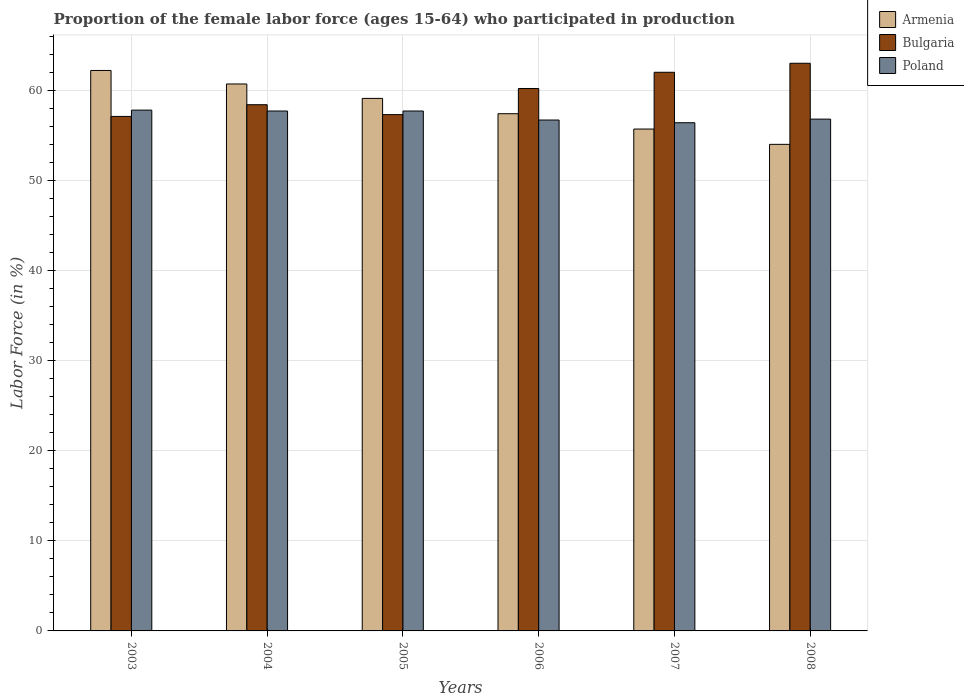How many different coloured bars are there?
Give a very brief answer. 3. How many groups of bars are there?
Offer a very short reply. 6. Are the number of bars per tick equal to the number of legend labels?
Provide a succinct answer. Yes. Are the number of bars on each tick of the X-axis equal?
Give a very brief answer. Yes. What is the label of the 2nd group of bars from the left?
Keep it short and to the point. 2004. In how many cases, is the number of bars for a given year not equal to the number of legend labels?
Keep it short and to the point. 0. Across all years, what is the maximum proportion of the female labor force who participated in production in Poland?
Your answer should be very brief. 57.8. Across all years, what is the minimum proportion of the female labor force who participated in production in Armenia?
Your response must be concise. 54. In which year was the proportion of the female labor force who participated in production in Bulgaria minimum?
Ensure brevity in your answer.  2003. What is the total proportion of the female labor force who participated in production in Bulgaria in the graph?
Keep it short and to the point. 358. What is the difference between the proportion of the female labor force who participated in production in Armenia in 2004 and that in 2005?
Give a very brief answer. 1.6. What is the average proportion of the female labor force who participated in production in Bulgaria per year?
Provide a succinct answer. 59.67. In the year 2007, what is the difference between the proportion of the female labor force who participated in production in Armenia and proportion of the female labor force who participated in production in Poland?
Provide a succinct answer. -0.7. In how many years, is the proportion of the female labor force who participated in production in Armenia greater than 44 %?
Ensure brevity in your answer.  6. What is the ratio of the proportion of the female labor force who participated in production in Armenia in 2005 to that in 2007?
Offer a very short reply. 1.06. Is the proportion of the female labor force who participated in production in Armenia in 2004 less than that in 2008?
Your answer should be very brief. No. Is the difference between the proportion of the female labor force who participated in production in Armenia in 2003 and 2005 greater than the difference between the proportion of the female labor force who participated in production in Poland in 2003 and 2005?
Give a very brief answer. Yes. What is the difference between the highest and the second highest proportion of the female labor force who participated in production in Poland?
Your answer should be very brief. 0.1. What is the difference between the highest and the lowest proportion of the female labor force who participated in production in Poland?
Give a very brief answer. 1.4. In how many years, is the proportion of the female labor force who participated in production in Poland greater than the average proportion of the female labor force who participated in production in Poland taken over all years?
Make the answer very short. 3. What does the 1st bar from the left in 2007 represents?
Your response must be concise. Armenia. What does the 3rd bar from the right in 2007 represents?
Your answer should be very brief. Armenia. What is the difference between two consecutive major ticks on the Y-axis?
Your answer should be compact. 10. Are the values on the major ticks of Y-axis written in scientific E-notation?
Give a very brief answer. No. Does the graph contain any zero values?
Offer a terse response. No. Does the graph contain grids?
Offer a terse response. Yes. What is the title of the graph?
Your response must be concise. Proportion of the female labor force (ages 15-64) who participated in production. Does "Singapore" appear as one of the legend labels in the graph?
Your answer should be compact. No. What is the label or title of the Y-axis?
Offer a terse response. Labor Force (in %). What is the Labor Force (in %) in Armenia in 2003?
Provide a succinct answer. 62.2. What is the Labor Force (in %) in Bulgaria in 2003?
Provide a short and direct response. 57.1. What is the Labor Force (in %) of Poland in 2003?
Your answer should be compact. 57.8. What is the Labor Force (in %) of Armenia in 2004?
Make the answer very short. 60.7. What is the Labor Force (in %) of Bulgaria in 2004?
Offer a very short reply. 58.4. What is the Labor Force (in %) of Poland in 2004?
Provide a succinct answer. 57.7. What is the Labor Force (in %) in Armenia in 2005?
Your response must be concise. 59.1. What is the Labor Force (in %) of Bulgaria in 2005?
Your answer should be very brief. 57.3. What is the Labor Force (in %) of Poland in 2005?
Keep it short and to the point. 57.7. What is the Labor Force (in %) of Armenia in 2006?
Your response must be concise. 57.4. What is the Labor Force (in %) in Bulgaria in 2006?
Your response must be concise. 60.2. What is the Labor Force (in %) in Poland in 2006?
Keep it short and to the point. 56.7. What is the Labor Force (in %) in Armenia in 2007?
Your answer should be compact. 55.7. What is the Labor Force (in %) in Poland in 2007?
Keep it short and to the point. 56.4. What is the Labor Force (in %) in Armenia in 2008?
Offer a terse response. 54. What is the Labor Force (in %) in Bulgaria in 2008?
Offer a very short reply. 63. What is the Labor Force (in %) of Poland in 2008?
Ensure brevity in your answer.  56.8. Across all years, what is the maximum Labor Force (in %) of Armenia?
Provide a short and direct response. 62.2. Across all years, what is the maximum Labor Force (in %) in Bulgaria?
Your response must be concise. 63. Across all years, what is the maximum Labor Force (in %) of Poland?
Your answer should be compact. 57.8. Across all years, what is the minimum Labor Force (in %) in Armenia?
Give a very brief answer. 54. Across all years, what is the minimum Labor Force (in %) in Bulgaria?
Give a very brief answer. 57.1. Across all years, what is the minimum Labor Force (in %) in Poland?
Make the answer very short. 56.4. What is the total Labor Force (in %) of Armenia in the graph?
Provide a succinct answer. 349.1. What is the total Labor Force (in %) of Bulgaria in the graph?
Offer a very short reply. 358. What is the total Labor Force (in %) in Poland in the graph?
Your answer should be very brief. 343.1. What is the difference between the Labor Force (in %) of Bulgaria in 2003 and that in 2004?
Offer a very short reply. -1.3. What is the difference between the Labor Force (in %) of Poland in 2003 and that in 2004?
Offer a terse response. 0.1. What is the difference between the Labor Force (in %) of Armenia in 2003 and that in 2005?
Make the answer very short. 3.1. What is the difference between the Labor Force (in %) of Bulgaria in 2003 and that in 2005?
Ensure brevity in your answer.  -0.2. What is the difference between the Labor Force (in %) of Poland in 2003 and that in 2005?
Offer a terse response. 0.1. What is the difference between the Labor Force (in %) of Bulgaria in 2003 and that in 2006?
Your response must be concise. -3.1. What is the difference between the Labor Force (in %) of Poland in 2003 and that in 2006?
Keep it short and to the point. 1.1. What is the difference between the Labor Force (in %) in Armenia in 2003 and that in 2007?
Make the answer very short. 6.5. What is the difference between the Labor Force (in %) in Bulgaria in 2003 and that in 2008?
Ensure brevity in your answer.  -5.9. What is the difference between the Labor Force (in %) in Poland in 2003 and that in 2008?
Give a very brief answer. 1. What is the difference between the Labor Force (in %) in Bulgaria in 2004 and that in 2006?
Your answer should be compact. -1.8. What is the difference between the Labor Force (in %) of Poland in 2004 and that in 2006?
Make the answer very short. 1. What is the difference between the Labor Force (in %) of Bulgaria in 2004 and that in 2007?
Give a very brief answer. -3.6. What is the difference between the Labor Force (in %) of Bulgaria in 2005 and that in 2006?
Your answer should be compact. -2.9. What is the difference between the Labor Force (in %) in Poland in 2005 and that in 2006?
Give a very brief answer. 1. What is the difference between the Labor Force (in %) in Poland in 2005 and that in 2007?
Offer a very short reply. 1.3. What is the difference between the Labor Force (in %) of Bulgaria in 2005 and that in 2008?
Make the answer very short. -5.7. What is the difference between the Labor Force (in %) of Poland in 2005 and that in 2008?
Give a very brief answer. 0.9. What is the difference between the Labor Force (in %) of Armenia in 2006 and that in 2007?
Provide a succinct answer. 1.7. What is the difference between the Labor Force (in %) in Poland in 2006 and that in 2007?
Your answer should be very brief. 0.3. What is the difference between the Labor Force (in %) in Poland in 2006 and that in 2008?
Provide a short and direct response. -0.1. What is the difference between the Labor Force (in %) of Poland in 2007 and that in 2008?
Ensure brevity in your answer.  -0.4. What is the difference between the Labor Force (in %) of Bulgaria in 2003 and the Labor Force (in %) of Poland in 2004?
Keep it short and to the point. -0.6. What is the difference between the Labor Force (in %) in Armenia in 2003 and the Labor Force (in %) in Bulgaria in 2006?
Keep it short and to the point. 2. What is the difference between the Labor Force (in %) in Armenia in 2003 and the Labor Force (in %) in Poland in 2006?
Make the answer very short. 5.5. What is the difference between the Labor Force (in %) in Armenia in 2003 and the Labor Force (in %) in Bulgaria in 2007?
Provide a succinct answer. 0.2. What is the difference between the Labor Force (in %) in Bulgaria in 2003 and the Labor Force (in %) in Poland in 2007?
Provide a short and direct response. 0.7. What is the difference between the Labor Force (in %) of Armenia in 2003 and the Labor Force (in %) of Poland in 2008?
Provide a succinct answer. 5.4. What is the difference between the Labor Force (in %) in Bulgaria in 2003 and the Labor Force (in %) in Poland in 2008?
Give a very brief answer. 0.3. What is the difference between the Labor Force (in %) of Armenia in 2004 and the Labor Force (in %) of Poland in 2005?
Offer a very short reply. 3. What is the difference between the Labor Force (in %) in Bulgaria in 2004 and the Labor Force (in %) in Poland in 2005?
Give a very brief answer. 0.7. What is the difference between the Labor Force (in %) of Armenia in 2004 and the Labor Force (in %) of Bulgaria in 2006?
Provide a succinct answer. 0.5. What is the difference between the Labor Force (in %) in Bulgaria in 2004 and the Labor Force (in %) in Poland in 2006?
Your answer should be very brief. 1.7. What is the difference between the Labor Force (in %) of Armenia in 2004 and the Labor Force (in %) of Bulgaria in 2007?
Give a very brief answer. -1.3. What is the difference between the Labor Force (in %) in Armenia in 2004 and the Labor Force (in %) in Poland in 2007?
Offer a very short reply. 4.3. What is the difference between the Labor Force (in %) in Armenia in 2004 and the Labor Force (in %) in Bulgaria in 2008?
Offer a very short reply. -2.3. What is the difference between the Labor Force (in %) of Armenia in 2004 and the Labor Force (in %) of Poland in 2008?
Provide a succinct answer. 3.9. What is the difference between the Labor Force (in %) of Bulgaria in 2004 and the Labor Force (in %) of Poland in 2008?
Keep it short and to the point. 1.6. What is the difference between the Labor Force (in %) in Armenia in 2005 and the Labor Force (in %) in Bulgaria in 2006?
Make the answer very short. -1.1. What is the difference between the Labor Force (in %) of Armenia in 2005 and the Labor Force (in %) of Bulgaria in 2008?
Your response must be concise. -3.9. What is the difference between the Labor Force (in %) of Armenia in 2005 and the Labor Force (in %) of Poland in 2008?
Provide a succinct answer. 2.3. What is the difference between the Labor Force (in %) of Bulgaria in 2005 and the Labor Force (in %) of Poland in 2008?
Your answer should be compact. 0.5. What is the difference between the Labor Force (in %) of Armenia in 2006 and the Labor Force (in %) of Poland in 2007?
Your response must be concise. 1. What is the difference between the Labor Force (in %) of Bulgaria in 2006 and the Labor Force (in %) of Poland in 2008?
Give a very brief answer. 3.4. What is the average Labor Force (in %) of Armenia per year?
Keep it short and to the point. 58.18. What is the average Labor Force (in %) in Bulgaria per year?
Your answer should be compact. 59.67. What is the average Labor Force (in %) of Poland per year?
Your response must be concise. 57.18. In the year 2005, what is the difference between the Labor Force (in %) in Armenia and Labor Force (in %) in Bulgaria?
Your answer should be very brief. 1.8. In the year 2005, what is the difference between the Labor Force (in %) of Armenia and Labor Force (in %) of Poland?
Make the answer very short. 1.4. In the year 2007, what is the difference between the Labor Force (in %) of Armenia and Labor Force (in %) of Bulgaria?
Offer a very short reply. -6.3. In the year 2008, what is the difference between the Labor Force (in %) in Armenia and Labor Force (in %) in Poland?
Give a very brief answer. -2.8. What is the ratio of the Labor Force (in %) of Armenia in 2003 to that in 2004?
Keep it short and to the point. 1.02. What is the ratio of the Labor Force (in %) of Bulgaria in 2003 to that in 2004?
Provide a short and direct response. 0.98. What is the ratio of the Labor Force (in %) in Poland in 2003 to that in 2004?
Offer a terse response. 1. What is the ratio of the Labor Force (in %) in Armenia in 2003 to that in 2005?
Your answer should be very brief. 1.05. What is the ratio of the Labor Force (in %) in Armenia in 2003 to that in 2006?
Offer a very short reply. 1.08. What is the ratio of the Labor Force (in %) in Bulgaria in 2003 to that in 2006?
Offer a very short reply. 0.95. What is the ratio of the Labor Force (in %) of Poland in 2003 to that in 2006?
Your answer should be compact. 1.02. What is the ratio of the Labor Force (in %) in Armenia in 2003 to that in 2007?
Make the answer very short. 1.12. What is the ratio of the Labor Force (in %) of Bulgaria in 2003 to that in 2007?
Provide a succinct answer. 0.92. What is the ratio of the Labor Force (in %) of Poland in 2003 to that in 2007?
Keep it short and to the point. 1.02. What is the ratio of the Labor Force (in %) in Armenia in 2003 to that in 2008?
Your answer should be compact. 1.15. What is the ratio of the Labor Force (in %) of Bulgaria in 2003 to that in 2008?
Your answer should be very brief. 0.91. What is the ratio of the Labor Force (in %) in Poland in 2003 to that in 2008?
Make the answer very short. 1.02. What is the ratio of the Labor Force (in %) in Armenia in 2004 to that in 2005?
Your answer should be very brief. 1.03. What is the ratio of the Labor Force (in %) in Bulgaria in 2004 to that in 2005?
Provide a succinct answer. 1.02. What is the ratio of the Labor Force (in %) in Poland in 2004 to that in 2005?
Offer a very short reply. 1. What is the ratio of the Labor Force (in %) in Armenia in 2004 to that in 2006?
Make the answer very short. 1.06. What is the ratio of the Labor Force (in %) in Bulgaria in 2004 to that in 2006?
Give a very brief answer. 0.97. What is the ratio of the Labor Force (in %) of Poland in 2004 to that in 2006?
Make the answer very short. 1.02. What is the ratio of the Labor Force (in %) of Armenia in 2004 to that in 2007?
Ensure brevity in your answer.  1.09. What is the ratio of the Labor Force (in %) of Bulgaria in 2004 to that in 2007?
Provide a short and direct response. 0.94. What is the ratio of the Labor Force (in %) in Armenia in 2004 to that in 2008?
Offer a very short reply. 1.12. What is the ratio of the Labor Force (in %) of Bulgaria in 2004 to that in 2008?
Offer a terse response. 0.93. What is the ratio of the Labor Force (in %) of Poland in 2004 to that in 2008?
Keep it short and to the point. 1.02. What is the ratio of the Labor Force (in %) in Armenia in 2005 to that in 2006?
Keep it short and to the point. 1.03. What is the ratio of the Labor Force (in %) of Bulgaria in 2005 to that in 2006?
Give a very brief answer. 0.95. What is the ratio of the Labor Force (in %) of Poland in 2005 to that in 2006?
Give a very brief answer. 1.02. What is the ratio of the Labor Force (in %) in Armenia in 2005 to that in 2007?
Make the answer very short. 1.06. What is the ratio of the Labor Force (in %) in Bulgaria in 2005 to that in 2007?
Ensure brevity in your answer.  0.92. What is the ratio of the Labor Force (in %) in Armenia in 2005 to that in 2008?
Offer a terse response. 1.09. What is the ratio of the Labor Force (in %) in Bulgaria in 2005 to that in 2008?
Your response must be concise. 0.91. What is the ratio of the Labor Force (in %) in Poland in 2005 to that in 2008?
Your answer should be very brief. 1.02. What is the ratio of the Labor Force (in %) of Armenia in 2006 to that in 2007?
Make the answer very short. 1.03. What is the ratio of the Labor Force (in %) in Bulgaria in 2006 to that in 2007?
Make the answer very short. 0.97. What is the ratio of the Labor Force (in %) in Poland in 2006 to that in 2007?
Your answer should be compact. 1.01. What is the ratio of the Labor Force (in %) of Armenia in 2006 to that in 2008?
Offer a terse response. 1.06. What is the ratio of the Labor Force (in %) in Bulgaria in 2006 to that in 2008?
Provide a succinct answer. 0.96. What is the ratio of the Labor Force (in %) in Poland in 2006 to that in 2008?
Provide a short and direct response. 1. What is the ratio of the Labor Force (in %) of Armenia in 2007 to that in 2008?
Ensure brevity in your answer.  1.03. What is the ratio of the Labor Force (in %) of Bulgaria in 2007 to that in 2008?
Offer a terse response. 0.98. What is the difference between the highest and the second highest Labor Force (in %) of Armenia?
Provide a short and direct response. 1.5. What is the difference between the highest and the second highest Labor Force (in %) in Bulgaria?
Your answer should be compact. 1. What is the difference between the highest and the lowest Labor Force (in %) of Armenia?
Your answer should be very brief. 8.2. 